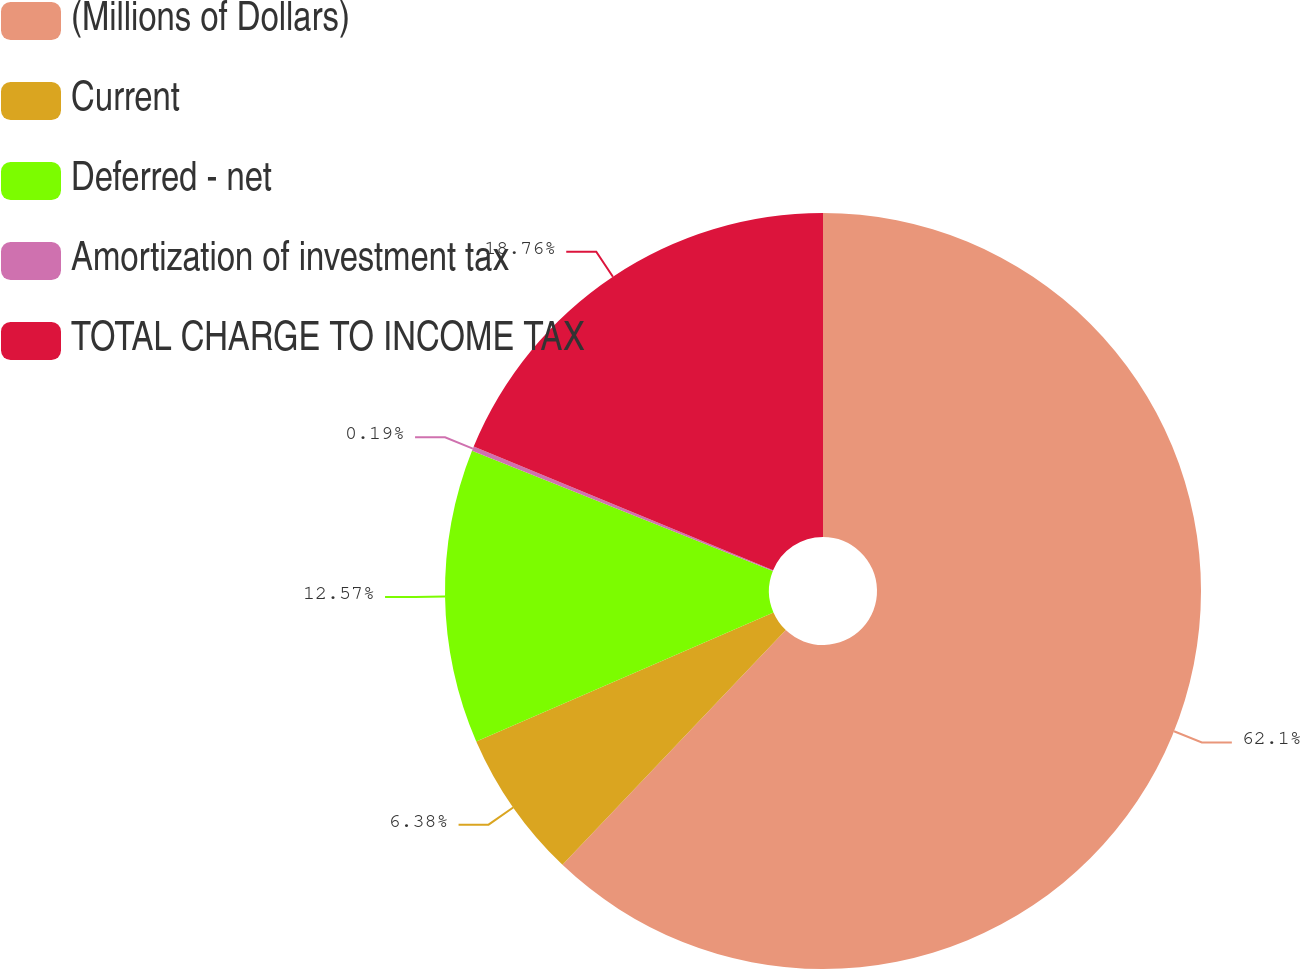Convert chart. <chart><loc_0><loc_0><loc_500><loc_500><pie_chart><fcel>(Millions of Dollars)<fcel>Current<fcel>Deferred - net<fcel>Amortization of investment tax<fcel>TOTAL CHARGE TO INCOME TAX<nl><fcel>62.11%<fcel>6.38%<fcel>12.57%<fcel>0.19%<fcel>18.76%<nl></chart> 